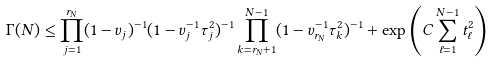Convert formula to latex. <formula><loc_0><loc_0><loc_500><loc_500>\Gamma ( N ) \leq \prod _ { j = 1 } ^ { r _ { N } } ( 1 - v _ { j } ) ^ { - 1 } ( 1 - v _ { j } ^ { - 1 } \tau _ { j } ^ { 2 } ) ^ { - 1 } \prod _ { k = r _ { N } + 1 } ^ { N - 1 } ( 1 - v _ { r _ { N } } ^ { - 1 } \tau _ { k } ^ { 2 } ) ^ { - 1 } + \exp \left ( C \sum _ { \ell = 1 } ^ { N - 1 } t _ { \ell } ^ { 2 } \right )</formula> 